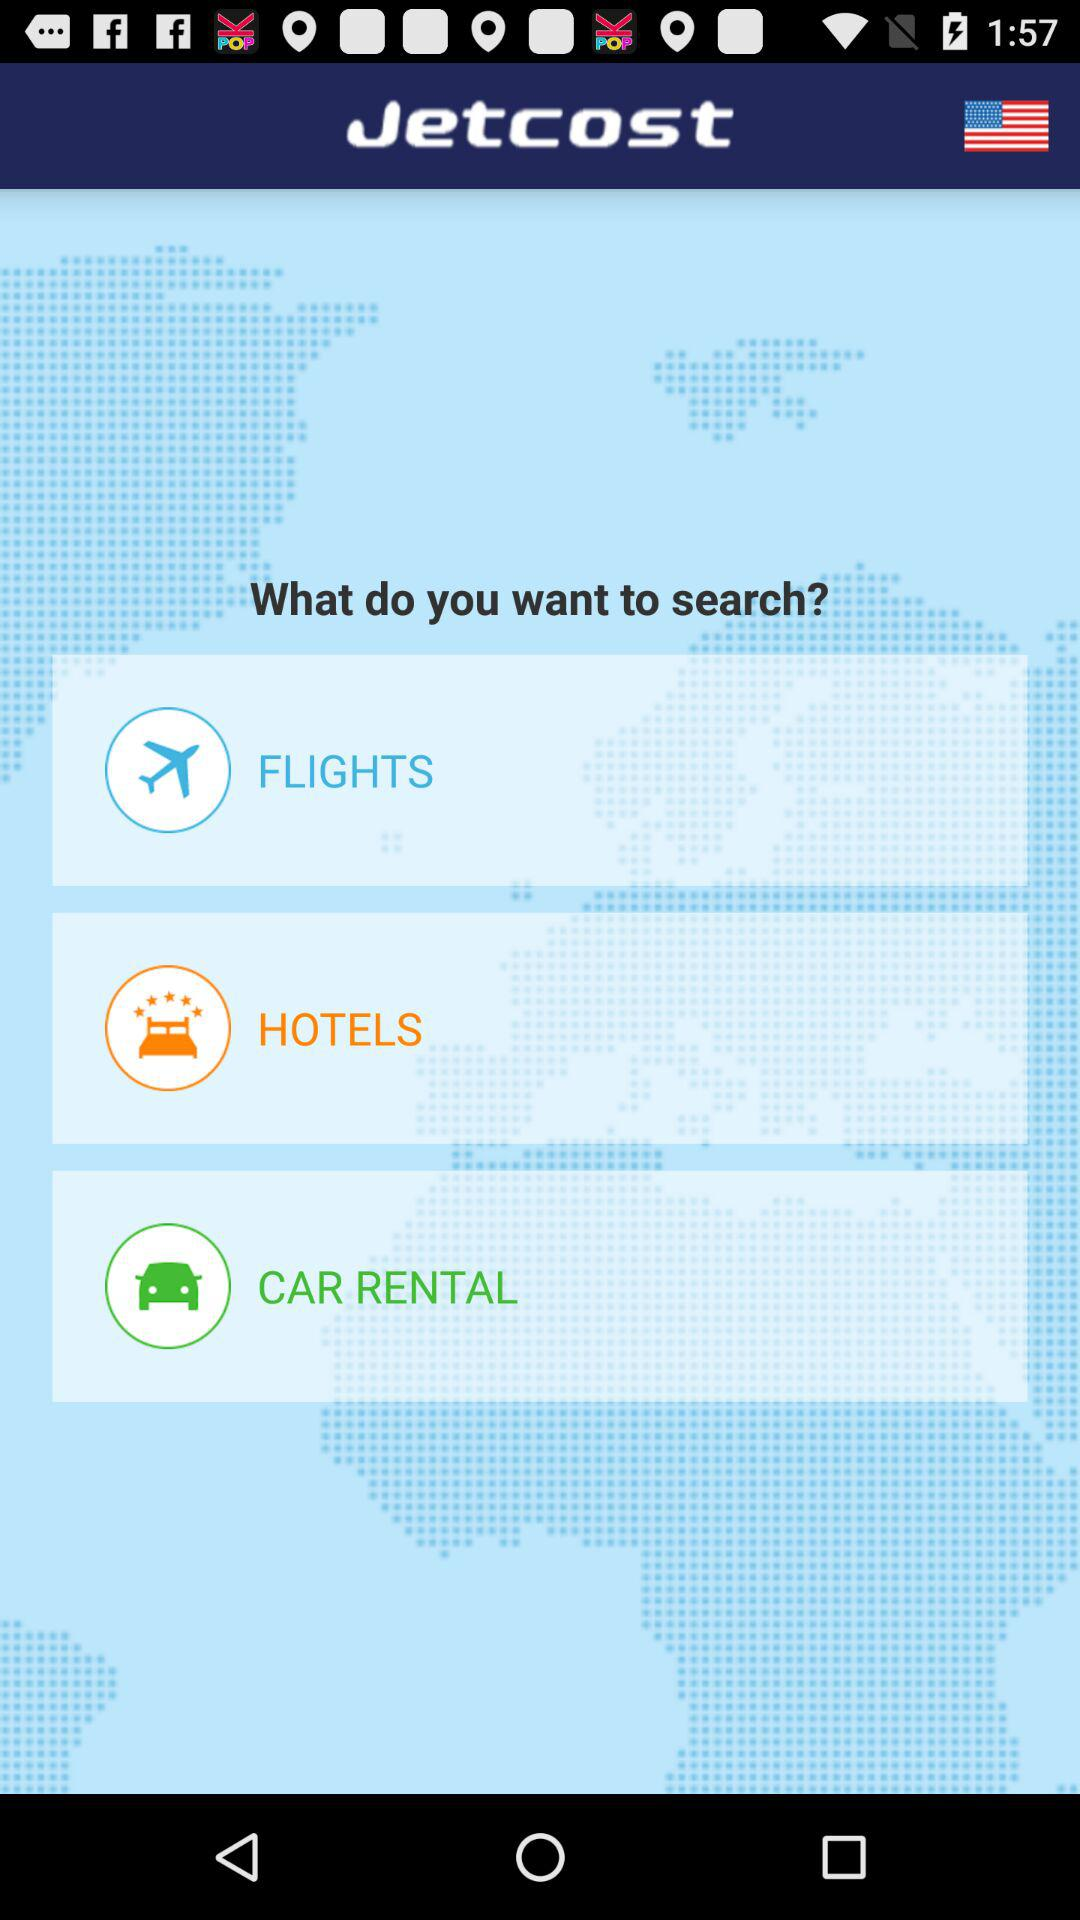What is the application name? The application name is "Jetcost". 